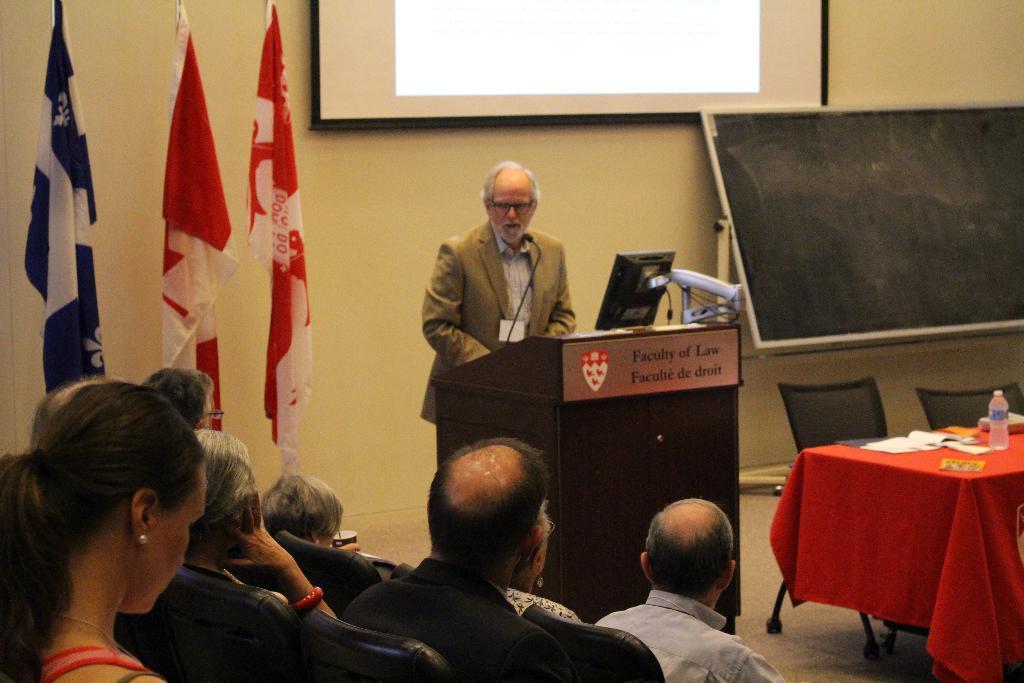Please provide a concise description of this image. In the picture we can see these people are sitting on the chairs and this person wearing blazer, shirt and identity card is standing near the podium where the monitor and mic are placed. On the right side of the image we can see a table upon which red color tablecloth, papers and bottle are places, we can see chairs, board, flags and the projector screen to the wall in the background. 